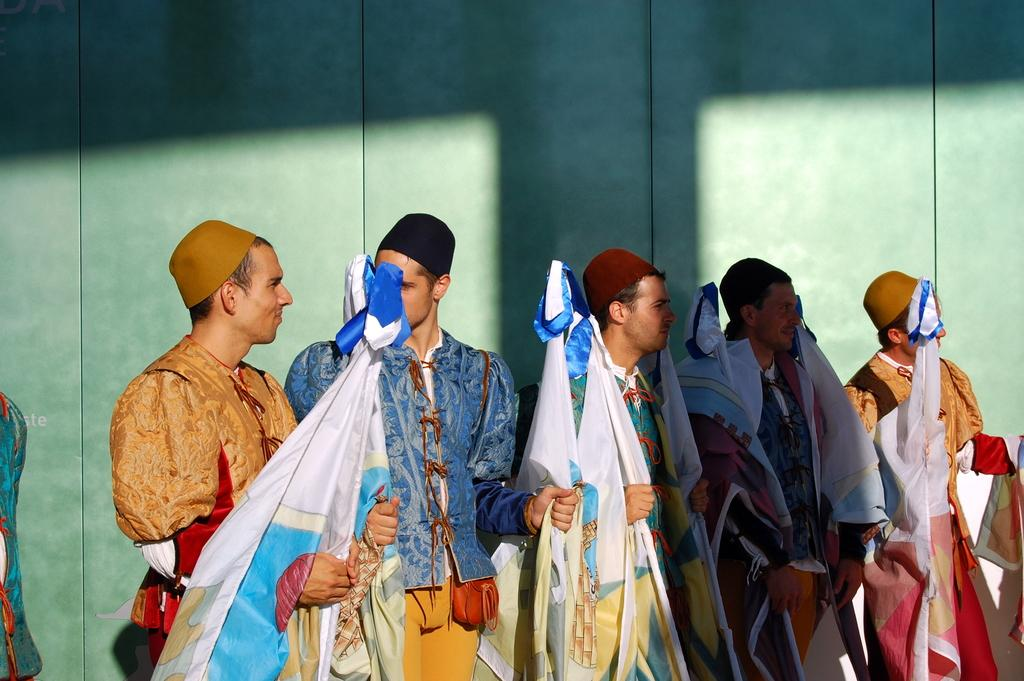Who or what is present in the image? There are people in the image. What are the people wearing on their heads? The people are wearing caps. What are the people holding in their hands? The people are holding something tied to a thread. What type of prose can be heard being recited by the people in the image? There is no indication in the image that the people are reciting any prose, so it cannot be determined from the picture. 